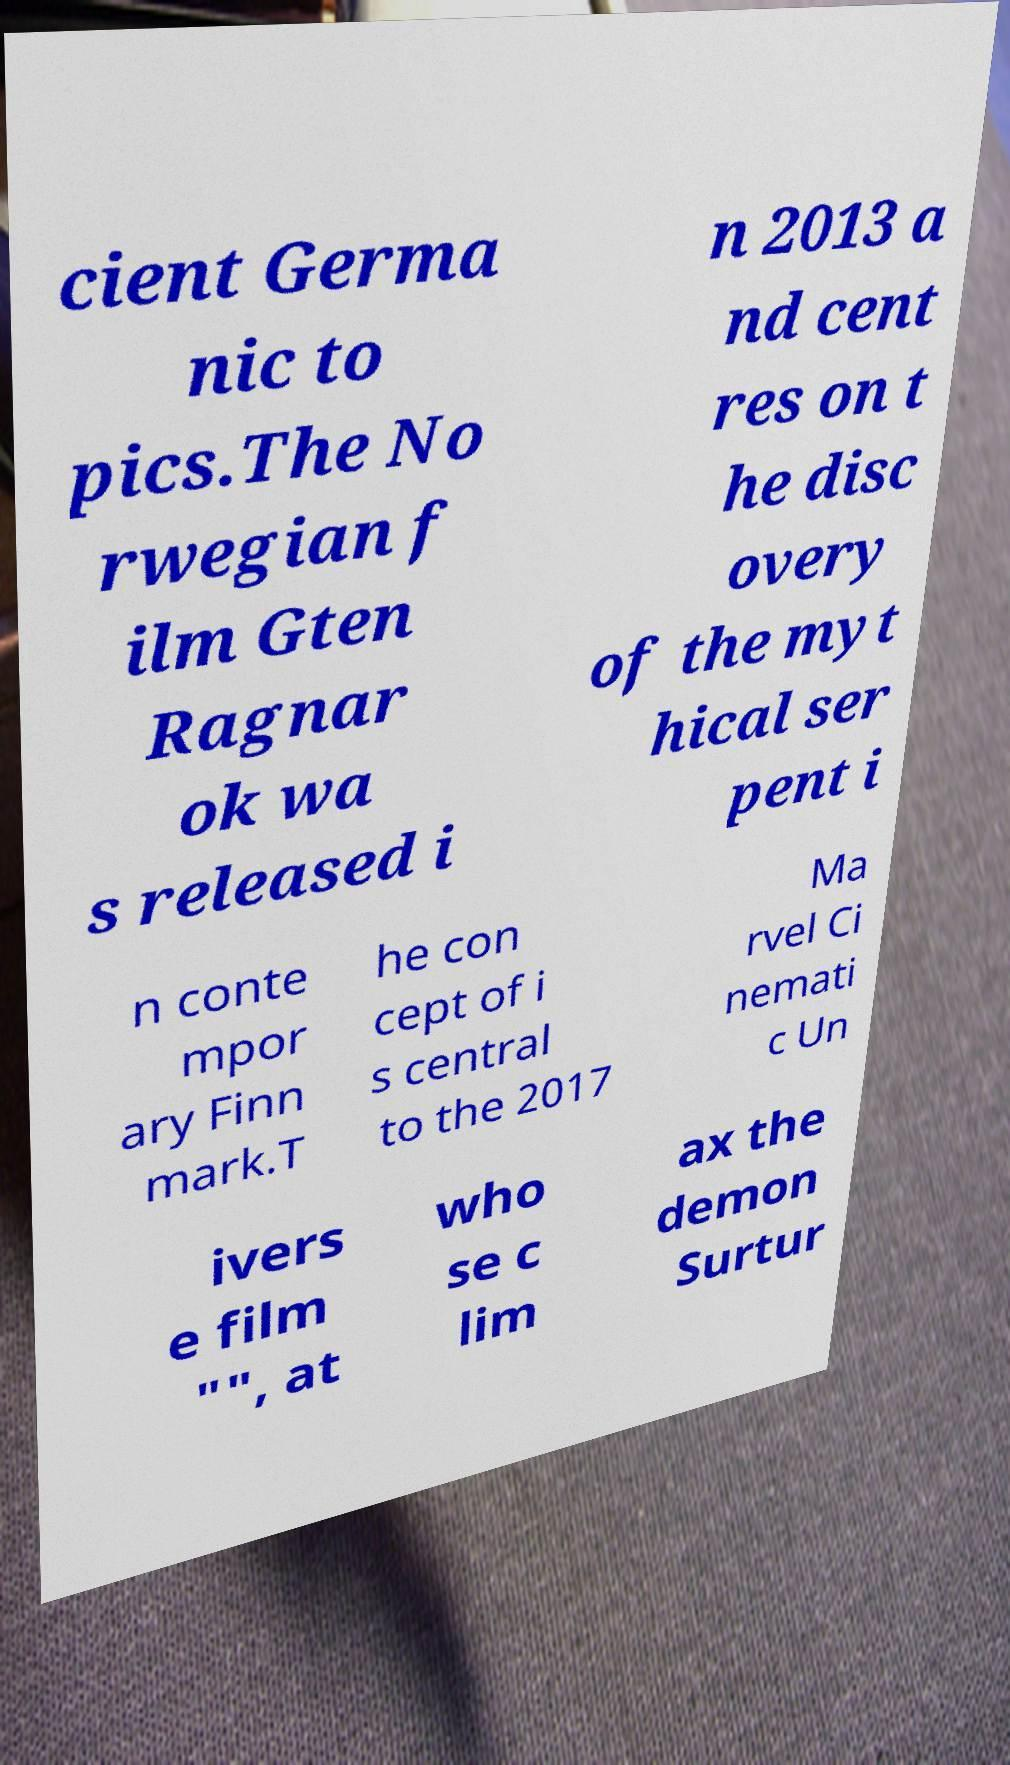For documentation purposes, I need the text within this image transcribed. Could you provide that? cient Germa nic to pics.The No rwegian f ilm Gten Ragnar ok wa s released i n 2013 a nd cent res on t he disc overy of the myt hical ser pent i n conte mpor ary Finn mark.T he con cept of i s central to the 2017 Ma rvel Ci nemati c Un ivers e film "", at who se c lim ax the demon Surtur 